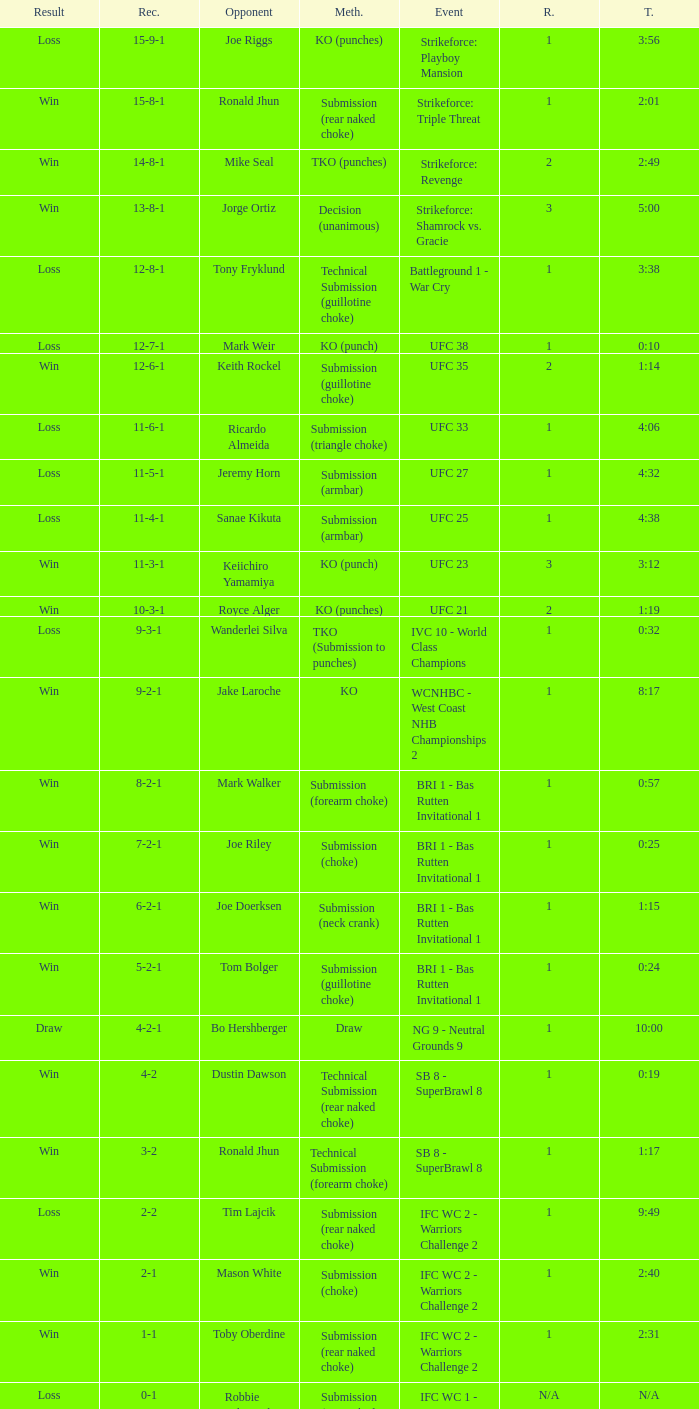What is the record when the fight was against keith rockel? 12-6-1. 